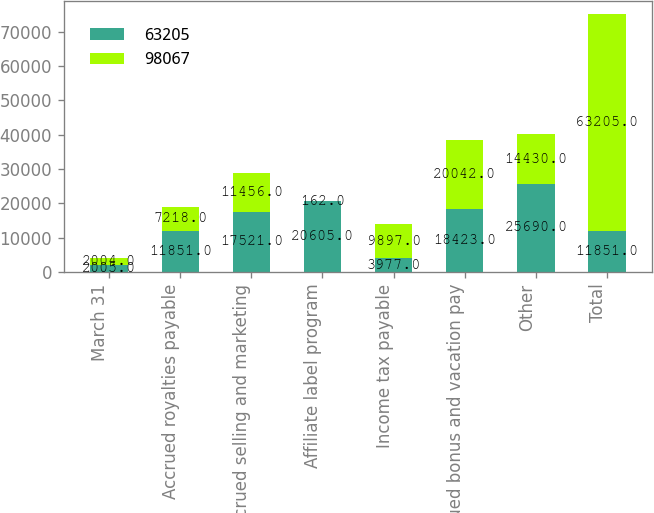Convert chart. <chart><loc_0><loc_0><loc_500><loc_500><stacked_bar_chart><ecel><fcel>March 31<fcel>Accrued royalties payable<fcel>Accrued selling and marketing<fcel>Affiliate label program<fcel>Income tax payable<fcel>Accrued bonus and vacation pay<fcel>Other<fcel>Total<nl><fcel>63205<fcel>2005<fcel>11851<fcel>17521<fcel>20605<fcel>3977<fcel>18423<fcel>25690<fcel>11851<nl><fcel>98067<fcel>2004<fcel>7218<fcel>11456<fcel>162<fcel>9897<fcel>20042<fcel>14430<fcel>63205<nl></chart> 